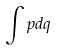Convert formula to latex. <formula><loc_0><loc_0><loc_500><loc_500>\int p d q</formula> 